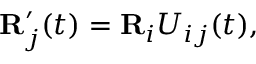Convert formula to latex. <formula><loc_0><loc_0><loc_500><loc_500>\begin{array} { r } { { R } _ { j } ^ { \prime } ( t ) = { R } _ { i } U _ { i j } ( t ) , } \end{array}</formula> 